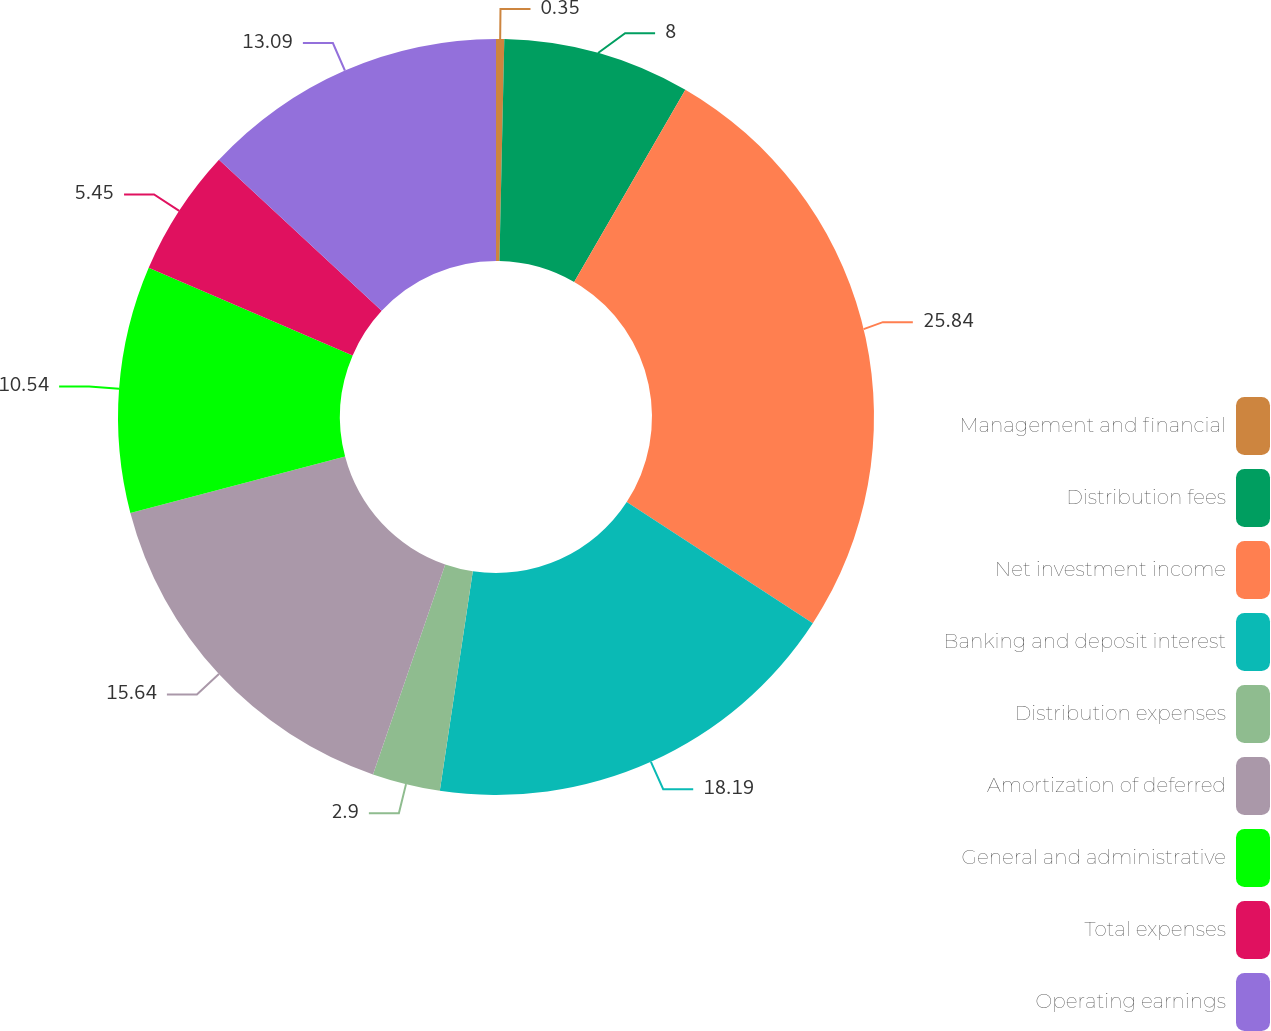<chart> <loc_0><loc_0><loc_500><loc_500><pie_chart><fcel>Management and financial<fcel>Distribution fees<fcel>Net investment income<fcel>Banking and deposit interest<fcel>Distribution expenses<fcel>Amortization of deferred<fcel>General and administrative<fcel>Total expenses<fcel>Operating earnings<nl><fcel>0.35%<fcel>8.0%<fcel>25.83%<fcel>18.19%<fcel>2.9%<fcel>15.64%<fcel>10.54%<fcel>5.45%<fcel>13.09%<nl></chart> 